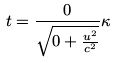Convert formula to latex. <formula><loc_0><loc_0><loc_500><loc_500>t = \frac { 0 } { \sqrt { 0 + \frac { u ^ { 2 } } { c ^ { 2 } } } } \kappa</formula> 